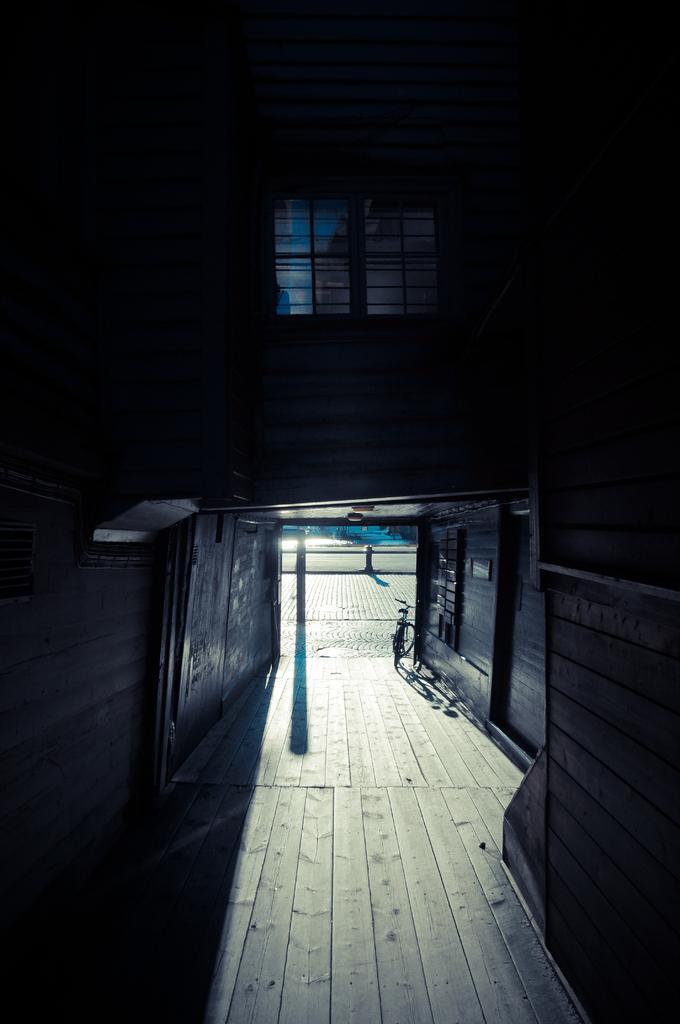Describe this image in one or two sentences. This is an image clicked in the dark. At the bottom, I can see the floor. At the top of the image there is window to the wall and it is dark. In the middle of the image there is a bicycle placed on the floor. In the background there is a road. 